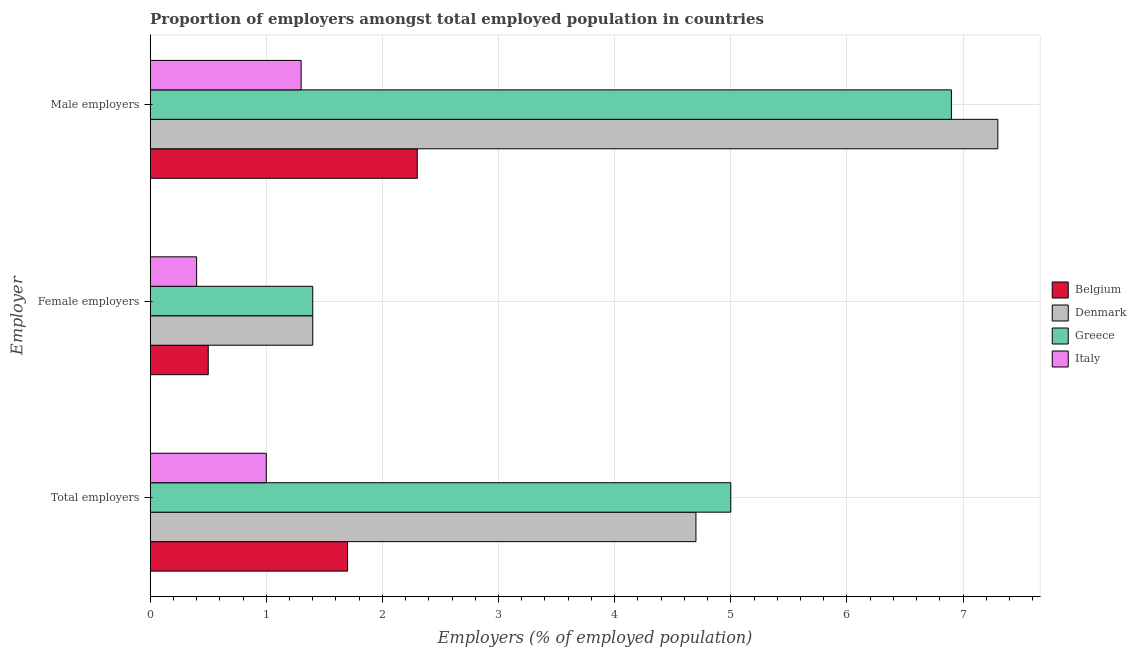Are the number of bars on each tick of the Y-axis equal?
Provide a succinct answer. Yes. How many bars are there on the 3rd tick from the top?
Offer a very short reply. 4. How many bars are there on the 1st tick from the bottom?
Provide a succinct answer. 4. What is the label of the 3rd group of bars from the top?
Ensure brevity in your answer.  Total employers. What is the percentage of male employers in Belgium?
Ensure brevity in your answer.  2.3. Across all countries, what is the maximum percentage of male employers?
Your answer should be very brief. 7.3. Across all countries, what is the minimum percentage of male employers?
Your response must be concise. 1.3. What is the total percentage of female employers in the graph?
Offer a very short reply. 3.7. What is the difference between the percentage of male employers in Belgium and that in Greece?
Provide a short and direct response. -4.6. What is the difference between the percentage of total employers in Denmark and the percentage of female employers in Greece?
Your response must be concise. 3.3. What is the average percentage of total employers per country?
Offer a very short reply. 3.1. What is the difference between the percentage of female employers and percentage of male employers in Belgium?
Provide a succinct answer. -1.8. In how many countries, is the percentage of male employers greater than 2.2 %?
Ensure brevity in your answer.  3. What is the ratio of the percentage of female employers in Belgium to that in Greece?
Your answer should be very brief. 0.36. Is the percentage of total employers in Belgium less than that in Greece?
Offer a very short reply. Yes. Is the difference between the percentage of total employers in Denmark and Italy greater than the difference between the percentage of male employers in Denmark and Italy?
Offer a very short reply. No. What is the difference between the highest and the second highest percentage of female employers?
Ensure brevity in your answer.  0. What is the difference between the highest and the lowest percentage of total employers?
Your answer should be compact. 4. What does the 4th bar from the bottom in Male employers represents?
Keep it short and to the point. Italy. Is it the case that in every country, the sum of the percentage of total employers and percentage of female employers is greater than the percentage of male employers?
Offer a terse response. No. Are all the bars in the graph horizontal?
Give a very brief answer. Yes. Does the graph contain any zero values?
Your response must be concise. No. What is the title of the graph?
Give a very brief answer. Proportion of employers amongst total employed population in countries. What is the label or title of the X-axis?
Your response must be concise. Employers (% of employed population). What is the label or title of the Y-axis?
Provide a succinct answer. Employer. What is the Employers (% of employed population) of Belgium in Total employers?
Your answer should be compact. 1.7. What is the Employers (% of employed population) in Denmark in Total employers?
Offer a very short reply. 4.7. What is the Employers (% of employed population) of Greece in Total employers?
Make the answer very short. 5. What is the Employers (% of employed population) of Italy in Total employers?
Make the answer very short. 1. What is the Employers (% of employed population) in Denmark in Female employers?
Make the answer very short. 1.4. What is the Employers (% of employed population) in Greece in Female employers?
Ensure brevity in your answer.  1.4. What is the Employers (% of employed population) of Italy in Female employers?
Provide a short and direct response. 0.4. What is the Employers (% of employed population) of Belgium in Male employers?
Make the answer very short. 2.3. What is the Employers (% of employed population) in Denmark in Male employers?
Offer a very short reply. 7.3. What is the Employers (% of employed population) in Greece in Male employers?
Your answer should be compact. 6.9. What is the Employers (% of employed population) of Italy in Male employers?
Provide a succinct answer. 1.3. Across all Employer, what is the maximum Employers (% of employed population) in Belgium?
Ensure brevity in your answer.  2.3. Across all Employer, what is the maximum Employers (% of employed population) in Denmark?
Provide a short and direct response. 7.3. Across all Employer, what is the maximum Employers (% of employed population) of Greece?
Keep it short and to the point. 6.9. Across all Employer, what is the maximum Employers (% of employed population) in Italy?
Your response must be concise. 1.3. Across all Employer, what is the minimum Employers (% of employed population) in Denmark?
Provide a short and direct response. 1.4. Across all Employer, what is the minimum Employers (% of employed population) of Greece?
Offer a very short reply. 1.4. Across all Employer, what is the minimum Employers (% of employed population) in Italy?
Your answer should be very brief. 0.4. What is the total Employers (% of employed population) in Belgium in the graph?
Your response must be concise. 4.5. What is the difference between the Employers (% of employed population) of Belgium in Total employers and that in Female employers?
Provide a succinct answer. 1.2. What is the difference between the Employers (% of employed population) in Italy in Total employers and that in Female employers?
Ensure brevity in your answer.  0.6. What is the difference between the Employers (% of employed population) in Denmark in Total employers and that in Male employers?
Offer a terse response. -2.6. What is the difference between the Employers (% of employed population) of Italy in Total employers and that in Male employers?
Ensure brevity in your answer.  -0.3. What is the difference between the Employers (% of employed population) in Denmark in Female employers and that in Male employers?
Ensure brevity in your answer.  -5.9. What is the difference between the Employers (% of employed population) in Italy in Female employers and that in Male employers?
Your answer should be very brief. -0.9. What is the difference between the Employers (% of employed population) of Belgium in Total employers and the Employers (% of employed population) of Denmark in Female employers?
Your answer should be very brief. 0.3. What is the difference between the Employers (% of employed population) in Belgium in Total employers and the Employers (% of employed population) in Greece in Female employers?
Give a very brief answer. 0.3. What is the difference between the Employers (% of employed population) in Belgium in Total employers and the Employers (% of employed population) in Italy in Female employers?
Offer a terse response. 1.3. What is the difference between the Employers (% of employed population) in Greece in Total employers and the Employers (% of employed population) in Italy in Female employers?
Provide a short and direct response. 4.6. What is the difference between the Employers (% of employed population) of Belgium in Total employers and the Employers (% of employed population) of Greece in Male employers?
Offer a very short reply. -5.2. What is the difference between the Employers (% of employed population) in Denmark in Total employers and the Employers (% of employed population) in Greece in Male employers?
Offer a very short reply. -2.2. What is the difference between the Employers (% of employed population) of Greece in Female employers and the Employers (% of employed population) of Italy in Male employers?
Your answer should be very brief. 0.1. What is the average Employers (% of employed population) of Belgium per Employer?
Provide a succinct answer. 1.5. What is the average Employers (% of employed population) in Denmark per Employer?
Give a very brief answer. 4.47. What is the average Employers (% of employed population) of Greece per Employer?
Offer a very short reply. 4.43. What is the difference between the Employers (% of employed population) of Belgium and Employers (% of employed population) of Denmark in Total employers?
Your response must be concise. -3. What is the difference between the Employers (% of employed population) of Denmark and Employers (% of employed population) of Greece in Total employers?
Your response must be concise. -0.3. What is the difference between the Employers (% of employed population) in Denmark and Employers (% of employed population) in Italy in Total employers?
Keep it short and to the point. 3.7. What is the difference between the Employers (% of employed population) of Greece and Employers (% of employed population) of Italy in Total employers?
Provide a short and direct response. 4. What is the difference between the Employers (% of employed population) in Belgium and Employers (% of employed population) in Denmark in Female employers?
Your response must be concise. -0.9. What is the difference between the Employers (% of employed population) in Belgium and Employers (% of employed population) in Greece in Female employers?
Your response must be concise. -0.9. What is the difference between the Employers (% of employed population) in Belgium and Employers (% of employed population) in Italy in Female employers?
Give a very brief answer. 0.1. What is the difference between the Employers (% of employed population) in Denmark and Employers (% of employed population) in Italy in Female employers?
Give a very brief answer. 1. What is the difference between the Employers (% of employed population) of Belgium and Employers (% of employed population) of Denmark in Male employers?
Give a very brief answer. -5. What is the difference between the Employers (% of employed population) of Denmark and Employers (% of employed population) of Greece in Male employers?
Offer a very short reply. 0.4. What is the difference between the Employers (% of employed population) in Denmark and Employers (% of employed population) in Italy in Male employers?
Your answer should be compact. 6. What is the ratio of the Employers (% of employed population) of Denmark in Total employers to that in Female employers?
Offer a terse response. 3.36. What is the ratio of the Employers (% of employed population) of Greece in Total employers to that in Female employers?
Offer a terse response. 3.57. What is the ratio of the Employers (% of employed population) in Italy in Total employers to that in Female employers?
Keep it short and to the point. 2.5. What is the ratio of the Employers (% of employed population) of Belgium in Total employers to that in Male employers?
Provide a short and direct response. 0.74. What is the ratio of the Employers (% of employed population) in Denmark in Total employers to that in Male employers?
Provide a succinct answer. 0.64. What is the ratio of the Employers (% of employed population) of Greece in Total employers to that in Male employers?
Ensure brevity in your answer.  0.72. What is the ratio of the Employers (% of employed population) in Italy in Total employers to that in Male employers?
Give a very brief answer. 0.77. What is the ratio of the Employers (% of employed population) of Belgium in Female employers to that in Male employers?
Provide a succinct answer. 0.22. What is the ratio of the Employers (% of employed population) in Denmark in Female employers to that in Male employers?
Provide a succinct answer. 0.19. What is the ratio of the Employers (% of employed population) of Greece in Female employers to that in Male employers?
Provide a short and direct response. 0.2. What is the ratio of the Employers (% of employed population) of Italy in Female employers to that in Male employers?
Provide a short and direct response. 0.31. What is the difference between the highest and the second highest Employers (% of employed population) in Belgium?
Your answer should be compact. 0.6. What is the difference between the highest and the second highest Employers (% of employed population) in Italy?
Keep it short and to the point. 0.3. What is the difference between the highest and the lowest Employers (% of employed population) of Belgium?
Provide a short and direct response. 1.8. What is the difference between the highest and the lowest Employers (% of employed population) in Denmark?
Your response must be concise. 5.9. 